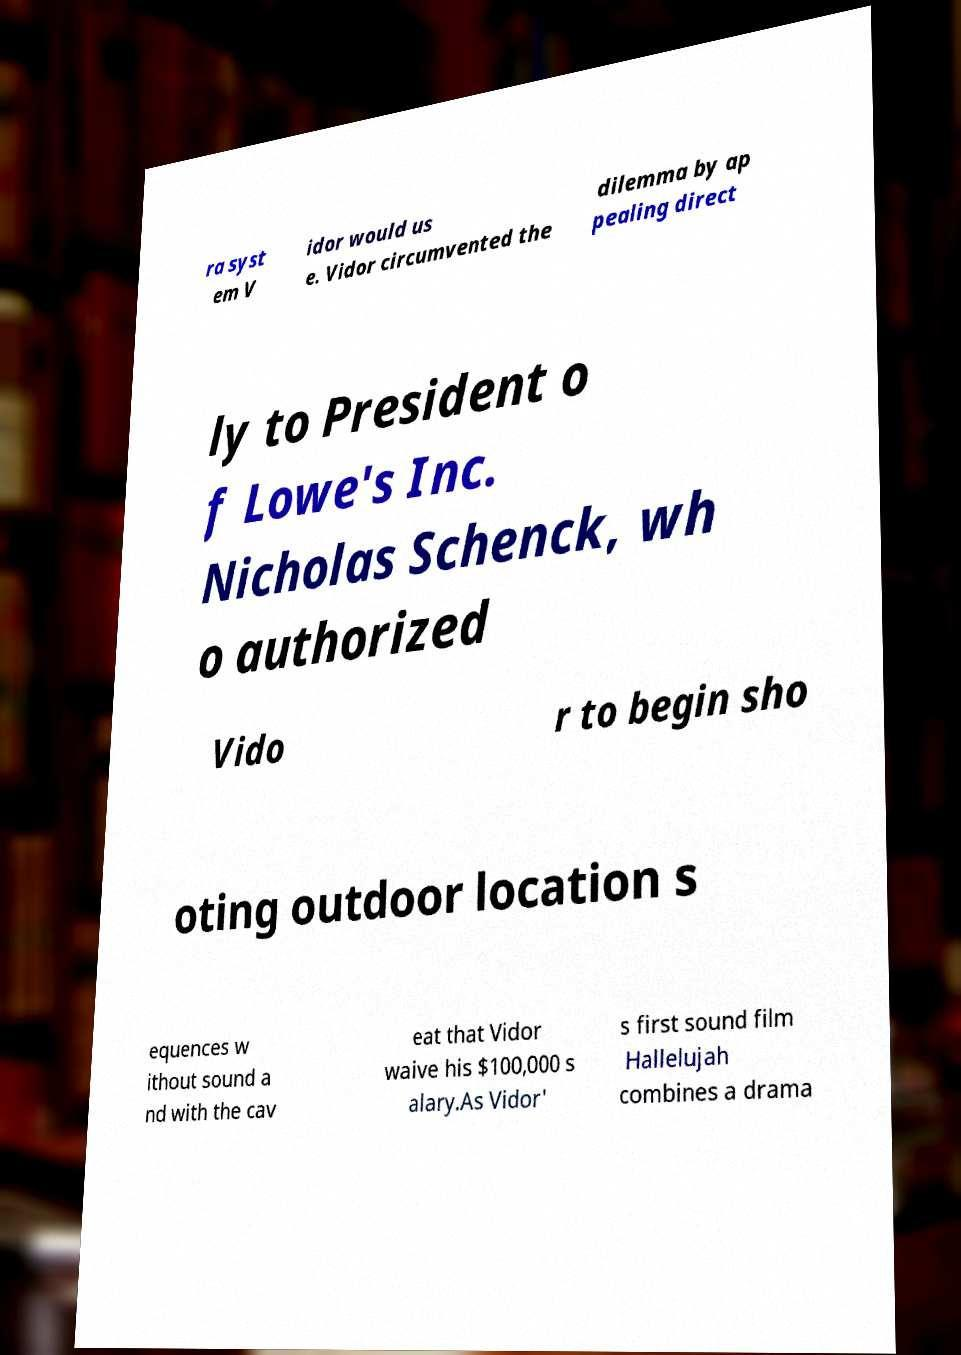Can you read and provide the text displayed in the image?This photo seems to have some interesting text. Can you extract and type it out for me? ra syst em V idor would us e. Vidor circumvented the dilemma by ap pealing direct ly to President o f Lowe's Inc. Nicholas Schenck, wh o authorized Vido r to begin sho oting outdoor location s equences w ithout sound a nd with the cav eat that Vidor waive his $100,000 s alary.As Vidor' s first sound film Hallelujah combines a drama 